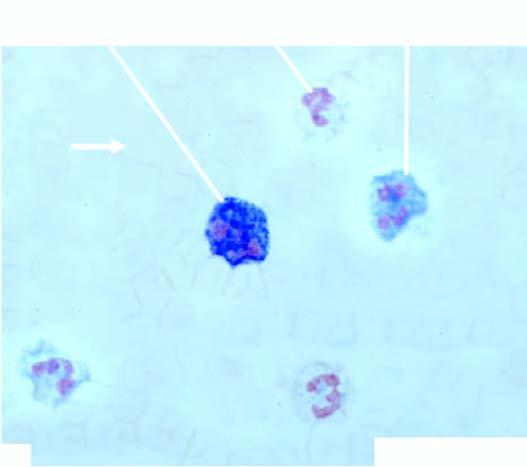re the mature red cells higher as demonstrated by this cytochemical stain?
Answer the question using a single word or phrase. No 